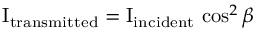Convert formula to latex. <formula><loc_0><loc_0><loc_500><loc_500>I _ { t r a n s m i t t e d } = I _ { i n c i d e n t } \, \cos ^ { 2 } { \beta }</formula> 